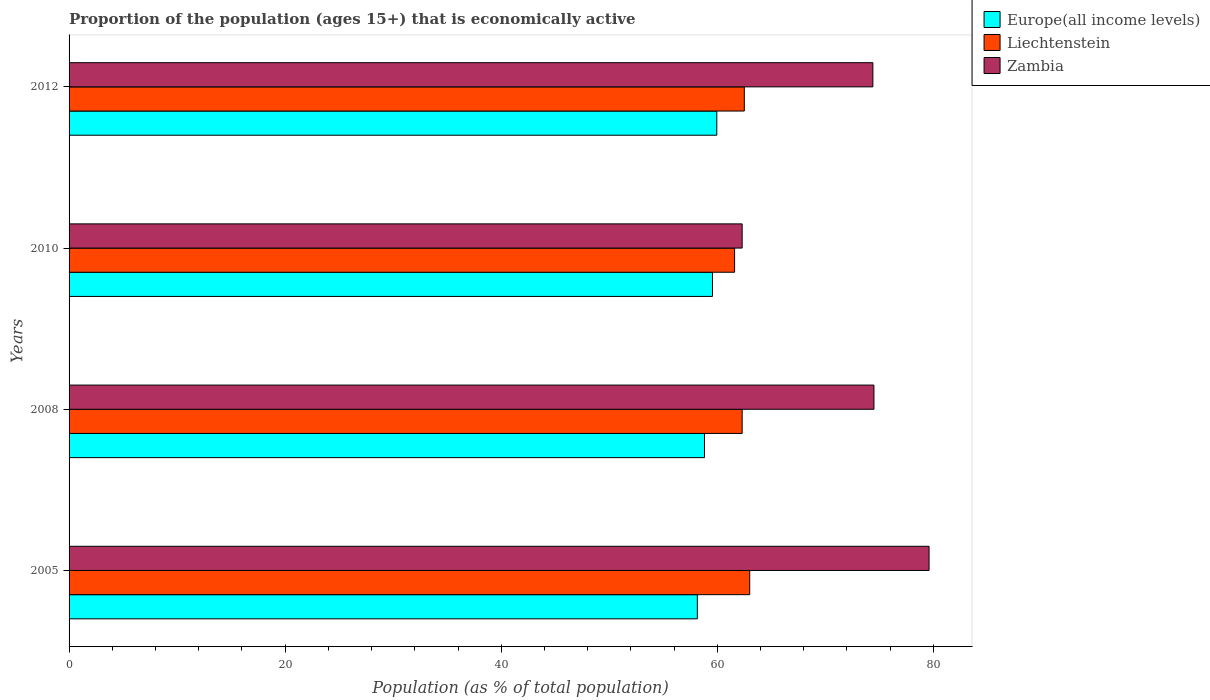Are the number of bars per tick equal to the number of legend labels?
Your response must be concise. Yes. Are the number of bars on each tick of the Y-axis equal?
Give a very brief answer. Yes. What is the label of the 3rd group of bars from the top?
Your answer should be very brief. 2008. What is the proportion of the population that is economically active in Europe(all income levels) in 2005?
Your answer should be compact. 58.15. Across all years, what is the maximum proportion of the population that is economically active in Zambia?
Make the answer very short. 79.6. Across all years, what is the minimum proportion of the population that is economically active in Zambia?
Keep it short and to the point. 62.3. In which year was the proportion of the population that is economically active in Europe(all income levels) maximum?
Make the answer very short. 2012. In which year was the proportion of the population that is economically active in Europe(all income levels) minimum?
Your response must be concise. 2005. What is the total proportion of the population that is economically active in Liechtenstein in the graph?
Keep it short and to the point. 249.4. What is the difference between the proportion of the population that is economically active in Liechtenstein in 2008 and that in 2012?
Offer a very short reply. -0.2. What is the difference between the proportion of the population that is economically active in Zambia in 2010 and the proportion of the population that is economically active in Liechtenstein in 2005?
Provide a short and direct response. -0.7. What is the average proportion of the population that is economically active in Europe(all income levels) per year?
Give a very brief answer. 59.12. In the year 2010, what is the difference between the proportion of the population that is economically active in Europe(all income levels) and proportion of the population that is economically active in Zambia?
Make the answer very short. -2.75. In how many years, is the proportion of the population that is economically active in Europe(all income levels) greater than 20 %?
Keep it short and to the point. 4. What is the ratio of the proportion of the population that is economically active in Zambia in 2010 to that in 2012?
Make the answer very short. 0.84. Is the proportion of the population that is economically active in Europe(all income levels) in 2005 less than that in 2008?
Give a very brief answer. Yes. What is the difference between the highest and the second highest proportion of the population that is economically active in Zambia?
Your response must be concise. 5.1. What is the difference between the highest and the lowest proportion of the population that is economically active in Europe(all income levels)?
Give a very brief answer. 1.8. In how many years, is the proportion of the population that is economically active in Liechtenstein greater than the average proportion of the population that is economically active in Liechtenstein taken over all years?
Keep it short and to the point. 2. Is the sum of the proportion of the population that is economically active in Zambia in 2005 and 2008 greater than the maximum proportion of the population that is economically active in Europe(all income levels) across all years?
Make the answer very short. Yes. What does the 2nd bar from the top in 2008 represents?
Make the answer very short. Liechtenstein. What does the 3rd bar from the bottom in 2012 represents?
Provide a short and direct response. Zambia. Is it the case that in every year, the sum of the proportion of the population that is economically active in Liechtenstein and proportion of the population that is economically active in Europe(all income levels) is greater than the proportion of the population that is economically active in Zambia?
Make the answer very short. Yes. How many bars are there?
Make the answer very short. 12. How many years are there in the graph?
Make the answer very short. 4. Does the graph contain any zero values?
Make the answer very short. No. Where does the legend appear in the graph?
Keep it short and to the point. Top right. How many legend labels are there?
Ensure brevity in your answer.  3. How are the legend labels stacked?
Provide a succinct answer. Vertical. What is the title of the graph?
Provide a succinct answer. Proportion of the population (ages 15+) that is economically active. What is the label or title of the X-axis?
Your response must be concise. Population (as % of total population). What is the label or title of the Y-axis?
Your answer should be very brief. Years. What is the Population (as % of total population) of Europe(all income levels) in 2005?
Your response must be concise. 58.15. What is the Population (as % of total population) in Zambia in 2005?
Your answer should be very brief. 79.6. What is the Population (as % of total population) of Europe(all income levels) in 2008?
Your answer should be compact. 58.81. What is the Population (as % of total population) in Liechtenstein in 2008?
Provide a succinct answer. 62.3. What is the Population (as % of total population) in Zambia in 2008?
Provide a short and direct response. 74.5. What is the Population (as % of total population) in Europe(all income levels) in 2010?
Keep it short and to the point. 59.55. What is the Population (as % of total population) in Liechtenstein in 2010?
Your answer should be compact. 61.6. What is the Population (as % of total population) of Zambia in 2010?
Give a very brief answer. 62.3. What is the Population (as % of total population) of Europe(all income levels) in 2012?
Ensure brevity in your answer.  59.95. What is the Population (as % of total population) in Liechtenstein in 2012?
Keep it short and to the point. 62.5. What is the Population (as % of total population) of Zambia in 2012?
Provide a succinct answer. 74.4. Across all years, what is the maximum Population (as % of total population) in Europe(all income levels)?
Keep it short and to the point. 59.95. Across all years, what is the maximum Population (as % of total population) of Zambia?
Make the answer very short. 79.6. Across all years, what is the minimum Population (as % of total population) of Europe(all income levels)?
Ensure brevity in your answer.  58.15. Across all years, what is the minimum Population (as % of total population) in Liechtenstein?
Keep it short and to the point. 61.6. Across all years, what is the minimum Population (as % of total population) of Zambia?
Provide a short and direct response. 62.3. What is the total Population (as % of total population) in Europe(all income levels) in the graph?
Keep it short and to the point. 236.47. What is the total Population (as % of total population) of Liechtenstein in the graph?
Your answer should be very brief. 249.4. What is the total Population (as % of total population) of Zambia in the graph?
Your response must be concise. 290.8. What is the difference between the Population (as % of total population) in Europe(all income levels) in 2005 and that in 2008?
Provide a succinct answer. -0.66. What is the difference between the Population (as % of total population) of Zambia in 2005 and that in 2008?
Provide a succinct answer. 5.1. What is the difference between the Population (as % of total population) in Europe(all income levels) in 2005 and that in 2010?
Keep it short and to the point. -1.4. What is the difference between the Population (as % of total population) in Zambia in 2005 and that in 2010?
Make the answer very short. 17.3. What is the difference between the Population (as % of total population) in Europe(all income levels) in 2005 and that in 2012?
Ensure brevity in your answer.  -1.8. What is the difference between the Population (as % of total population) of Europe(all income levels) in 2008 and that in 2010?
Provide a succinct answer. -0.74. What is the difference between the Population (as % of total population) in Liechtenstein in 2008 and that in 2010?
Provide a succinct answer. 0.7. What is the difference between the Population (as % of total population) in Zambia in 2008 and that in 2010?
Keep it short and to the point. 12.2. What is the difference between the Population (as % of total population) of Europe(all income levels) in 2008 and that in 2012?
Make the answer very short. -1.14. What is the difference between the Population (as % of total population) in Zambia in 2008 and that in 2012?
Offer a very short reply. 0.1. What is the difference between the Population (as % of total population) in Europe(all income levels) in 2010 and that in 2012?
Ensure brevity in your answer.  -0.4. What is the difference between the Population (as % of total population) in Liechtenstein in 2010 and that in 2012?
Provide a succinct answer. -0.9. What is the difference between the Population (as % of total population) of Europe(all income levels) in 2005 and the Population (as % of total population) of Liechtenstein in 2008?
Ensure brevity in your answer.  -4.15. What is the difference between the Population (as % of total population) in Europe(all income levels) in 2005 and the Population (as % of total population) in Zambia in 2008?
Give a very brief answer. -16.35. What is the difference between the Population (as % of total population) of Liechtenstein in 2005 and the Population (as % of total population) of Zambia in 2008?
Ensure brevity in your answer.  -11.5. What is the difference between the Population (as % of total population) of Europe(all income levels) in 2005 and the Population (as % of total population) of Liechtenstein in 2010?
Your response must be concise. -3.45. What is the difference between the Population (as % of total population) of Europe(all income levels) in 2005 and the Population (as % of total population) of Zambia in 2010?
Provide a short and direct response. -4.15. What is the difference between the Population (as % of total population) in Europe(all income levels) in 2005 and the Population (as % of total population) in Liechtenstein in 2012?
Provide a succinct answer. -4.35. What is the difference between the Population (as % of total population) of Europe(all income levels) in 2005 and the Population (as % of total population) of Zambia in 2012?
Your answer should be compact. -16.25. What is the difference between the Population (as % of total population) in Europe(all income levels) in 2008 and the Population (as % of total population) in Liechtenstein in 2010?
Offer a terse response. -2.79. What is the difference between the Population (as % of total population) of Europe(all income levels) in 2008 and the Population (as % of total population) of Zambia in 2010?
Ensure brevity in your answer.  -3.49. What is the difference between the Population (as % of total population) in Europe(all income levels) in 2008 and the Population (as % of total population) in Liechtenstein in 2012?
Make the answer very short. -3.69. What is the difference between the Population (as % of total population) of Europe(all income levels) in 2008 and the Population (as % of total population) of Zambia in 2012?
Your answer should be compact. -15.59. What is the difference between the Population (as % of total population) in Liechtenstein in 2008 and the Population (as % of total population) in Zambia in 2012?
Offer a terse response. -12.1. What is the difference between the Population (as % of total population) in Europe(all income levels) in 2010 and the Population (as % of total population) in Liechtenstein in 2012?
Your answer should be compact. -2.95. What is the difference between the Population (as % of total population) in Europe(all income levels) in 2010 and the Population (as % of total population) in Zambia in 2012?
Make the answer very short. -14.85. What is the difference between the Population (as % of total population) in Liechtenstein in 2010 and the Population (as % of total population) in Zambia in 2012?
Make the answer very short. -12.8. What is the average Population (as % of total population) of Europe(all income levels) per year?
Provide a short and direct response. 59.12. What is the average Population (as % of total population) in Liechtenstein per year?
Keep it short and to the point. 62.35. What is the average Population (as % of total population) in Zambia per year?
Your answer should be compact. 72.7. In the year 2005, what is the difference between the Population (as % of total population) of Europe(all income levels) and Population (as % of total population) of Liechtenstein?
Your response must be concise. -4.85. In the year 2005, what is the difference between the Population (as % of total population) in Europe(all income levels) and Population (as % of total population) in Zambia?
Offer a very short reply. -21.45. In the year 2005, what is the difference between the Population (as % of total population) in Liechtenstein and Population (as % of total population) in Zambia?
Provide a short and direct response. -16.6. In the year 2008, what is the difference between the Population (as % of total population) in Europe(all income levels) and Population (as % of total population) in Liechtenstein?
Your answer should be compact. -3.49. In the year 2008, what is the difference between the Population (as % of total population) of Europe(all income levels) and Population (as % of total population) of Zambia?
Provide a succinct answer. -15.69. In the year 2010, what is the difference between the Population (as % of total population) of Europe(all income levels) and Population (as % of total population) of Liechtenstein?
Ensure brevity in your answer.  -2.05. In the year 2010, what is the difference between the Population (as % of total population) in Europe(all income levels) and Population (as % of total population) in Zambia?
Give a very brief answer. -2.75. In the year 2012, what is the difference between the Population (as % of total population) of Europe(all income levels) and Population (as % of total population) of Liechtenstein?
Give a very brief answer. -2.55. In the year 2012, what is the difference between the Population (as % of total population) in Europe(all income levels) and Population (as % of total population) in Zambia?
Keep it short and to the point. -14.45. In the year 2012, what is the difference between the Population (as % of total population) in Liechtenstein and Population (as % of total population) in Zambia?
Make the answer very short. -11.9. What is the ratio of the Population (as % of total population) of Liechtenstein in 2005 to that in 2008?
Offer a very short reply. 1.01. What is the ratio of the Population (as % of total population) of Zambia in 2005 to that in 2008?
Your answer should be very brief. 1.07. What is the ratio of the Population (as % of total population) in Europe(all income levels) in 2005 to that in 2010?
Keep it short and to the point. 0.98. What is the ratio of the Population (as % of total population) in Liechtenstein in 2005 to that in 2010?
Ensure brevity in your answer.  1.02. What is the ratio of the Population (as % of total population) of Zambia in 2005 to that in 2010?
Provide a succinct answer. 1.28. What is the ratio of the Population (as % of total population) in Liechtenstein in 2005 to that in 2012?
Your answer should be compact. 1.01. What is the ratio of the Population (as % of total population) in Zambia in 2005 to that in 2012?
Make the answer very short. 1.07. What is the ratio of the Population (as % of total population) in Europe(all income levels) in 2008 to that in 2010?
Your answer should be compact. 0.99. What is the ratio of the Population (as % of total population) of Liechtenstein in 2008 to that in 2010?
Provide a succinct answer. 1.01. What is the ratio of the Population (as % of total population) in Zambia in 2008 to that in 2010?
Ensure brevity in your answer.  1.2. What is the ratio of the Population (as % of total population) of Europe(all income levels) in 2008 to that in 2012?
Provide a succinct answer. 0.98. What is the ratio of the Population (as % of total population) in Liechtenstein in 2008 to that in 2012?
Your response must be concise. 1. What is the ratio of the Population (as % of total population) of Zambia in 2008 to that in 2012?
Your response must be concise. 1. What is the ratio of the Population (as % of total population) of Europe(all income levels) in 2010 to that in 2012?
Your response must be concise. 0.99. What is the ratio of the Population (as % of total population) in Liechtenstein in 2010 to that in 2012?
Provide a short and direct response. 0.99. What is the ratio of the Population (as % of total population) in Zambia in 2010 to that in 2012?
Provide a succinct answer. 0.84. What is the difference between the highest and the second highest Population (as % of total population) in Europe(all income levels)?
Give a very brief answer. 0.4. What is the difference between the highest and the second highest Population (as % of total population) of Liechtenstein?
Your answer should be very brief. 0.5. What is the difference between the highest and the second highest Population (as % of total population) in Zambia?
Give a very brief answer. 5.1. What is the difference between the highest and the lowest Population (as % of total population) in Europe(all income levels)?
Your response must be concise. 1.8. What is the difference between the highest and the lowest Population (as % of total population) in Liechtenstein?
Provide a short and direct response. 1.4. 